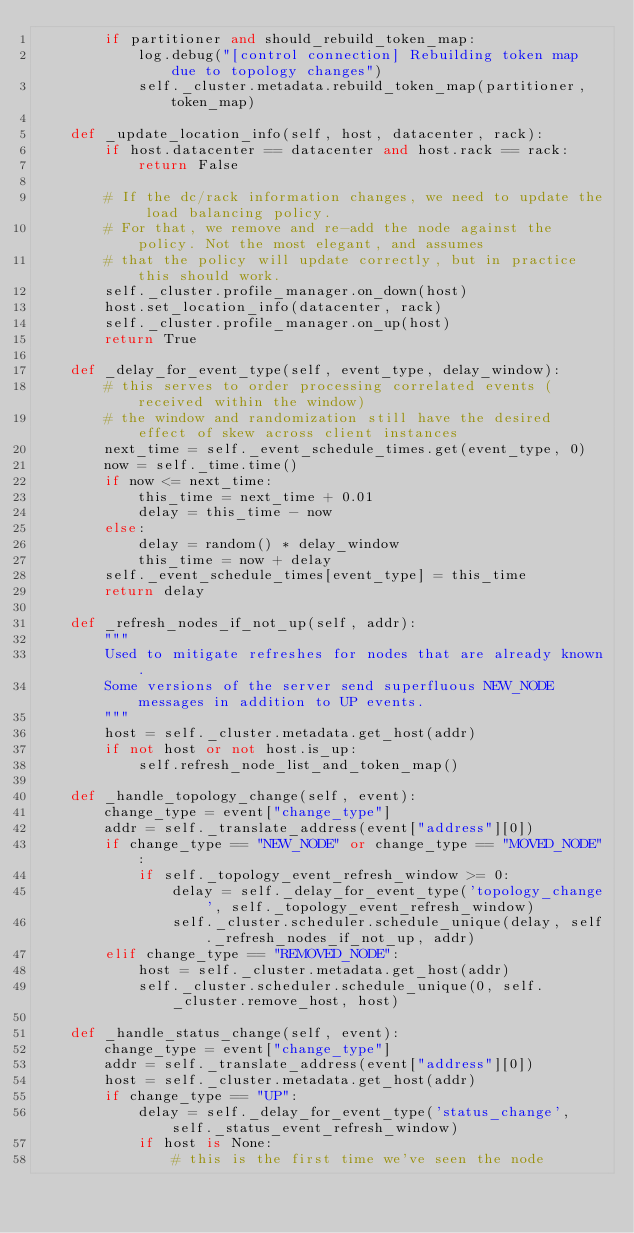<code> <loc_0><loc_0><loc_500><loc_500><_Python_>        if partitioner and should_rebuild_token_map:
            log.debug("[control connection] Rebuilding token map due to topology changes")
            self._cluster.metadata.rebuild_token_map(partitioner, token_map)

    def _update_location_info(self, host, datacenter, rack):
        if host.datacenter == datacenter and host.rack == rack:
            return False

        # If the dc/rack information changes, we need to update the load balancing policy.
        # For that, we remove and re-add the node against the policy. Not the most elegant, and assumes
        # that the policy will update correctly, but in practice this should work.
        self._cluster.profile_manager.on_down(host)
        host.set_location_info(datacenter, rack)
        self._cluster.profile_manager.on_up(host)
        return True

    def _delay_for_event_type(self, event_type, delay_window):
        # this serves to order processing correlated events (received within the window)
        # the window and randomization still have the desired effect of skew across client instances
        next_time = self._event_schedule_times.get(event_type, 0)
        now = self._time.time()
        if now <= next_time:
            this_time = next_time + 0.01
            delay = this_time - now
        else:
            delay = random() * delay_window
            this_time = now + delay
        self._event_schedule_times[event_type] = this_time
        return delay

    def _refresh_nodes_if_not_up(self, addr):
        """
        Used to mitigate refreshes for nodes that are already known.
        Some versions of the server send superfluous NEW_NODE messages in addition to UP events.
        """
        host = self._cluster.metadata.get_host(addr)
        if not host or not host.is_up:
            self.refresh_node_list_and_token_map()

    def _handle_topology_change(self, event):
        change_type = event["change_type"]
        addr = self._translate_address(event["address"][0])
        if change_type == "NEW_NODE" or change_type == "MOVED_NODE":
            if self._topology_event_refresh_window >= 0:
                delay = self._delay_for_event_type('topology_change', self._topology_event_refresh_window)
                self._cluster.scheduler.schedule_unique(delay, self._refresh_nodes_if_not_up, addr)
        elif change_type == "REMOVED_NODE":
            host = self._cluster.metadata.get_host(addr)
            self._cluster.scheduler.schedule_unique(0, self._cluster.remove_host, host)

    def _handle_status_change(self, event):
        change_type = event["change_type"]
        addr = self._translate_address(event["address"][0])
        host = self._cluster.metadata.get_host(addr)
        if change_type == "UP":
            delay = self._delay_for_event_type('status_change', self._status_event_refresh_window)
            if host is None:
                # this is the first time we've seen the node</code> 